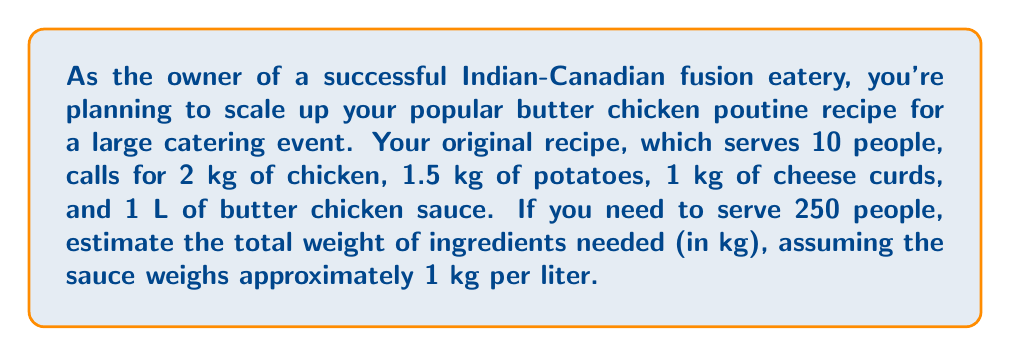Help me with this question. Let's approach this problem step-by-step:

1) First, we need to calculate the scaling factor:
   $$ \text{Scaling factor} = \frac{\text{New number of servings}}{\text{Original number of servings}} = \frac{250}{10} = 25 $$

2) Now, let's scale up each ingredient:

   Chicken: $2 \text{ kg} \times 25 = 50 \text{ kg}$
   Potatoes: $1.5 \text{ kg} \times 25 = 37.5 \text{ kg}$
   Cheese curds: $1 \text{ kg} \times 25 = 25 \text{ kg}$
   Butter chicken sauce: $1 \text{ L} \times 25 = 25 \text{ L} = 25 \text{ kg}$ (given 1 L ≈ 1 kg)

3) To find the total weight, we sum up all the ingredients:

   $$ \text{Total weight} = 50 + 37.5 + 25 + 25 = 137.5 \text{ kg} $$

Therefore, the estimated total weight of ingredients needed is 137.5 kg.
Answer: 137.5 kg 